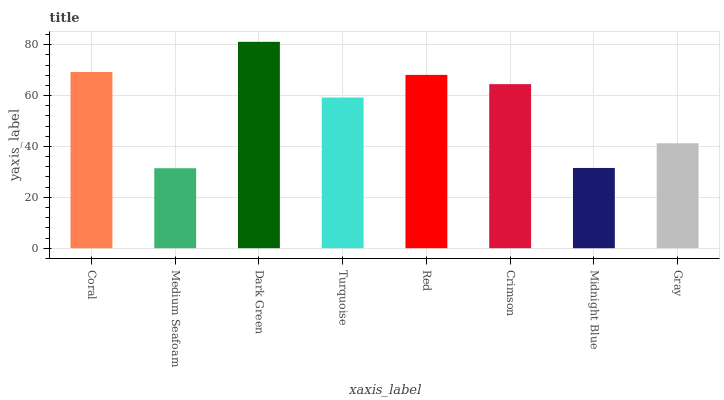Is Dark Green the minimum?
Answer yes or no. No. Is Medium Seafoam the maximum?
Answer yes or no. No. Is Dark Green greater than Medium Seafoam?
Answer yes or no. Yes. Is Medium Seafoam less than Dark Green?
Answer yes or no. Yes. Is Medium Seafoam greater than Dark Green?
Answer yes or no. No. Is Dark Green less than Medium Seafoam?
Answer yes or no. No. Is Crimson the high median?
Answer yes or no. Yes. Is Turquoise the low median?
Answer yes or no. Yes. Is Red the high median?
Answer yes or no. No. Is Red the low median?
Answer yes or no. No. 